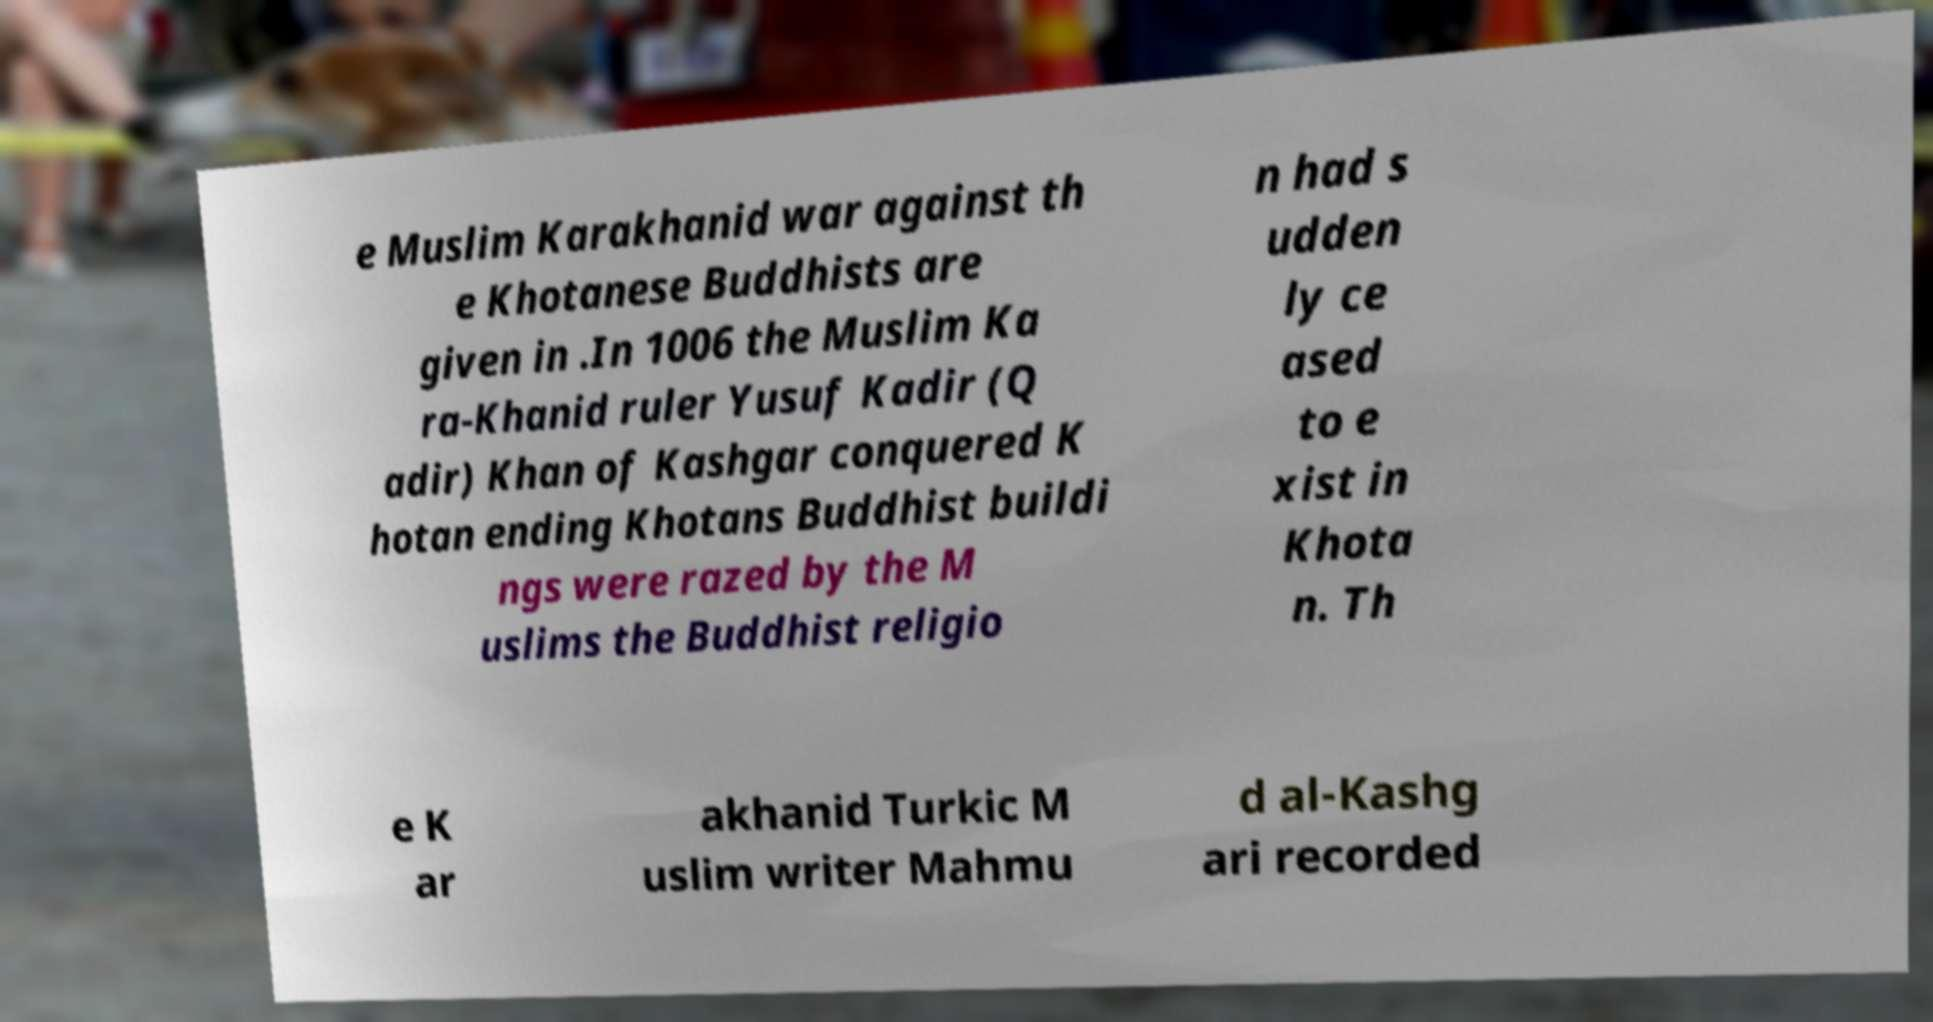Can you accurately transcribe the text from the provided image for me? e Muslim Karakhanid war against th e Khotanese Buddhists are given in .In 1006 the Muslim Ka ra-Khanid ruler Yusuf Kadir (Q adir) Khan of Kashgar conquered K hotan ending Khotans Buddhist buildi ngs were razed by the M uslims the Buddhist religio n had s udden ly ce ased to e xist in Khota n. Th e K ar akhanid Turkic M uslim writer Mahmu d al-Kashg ari recorded 